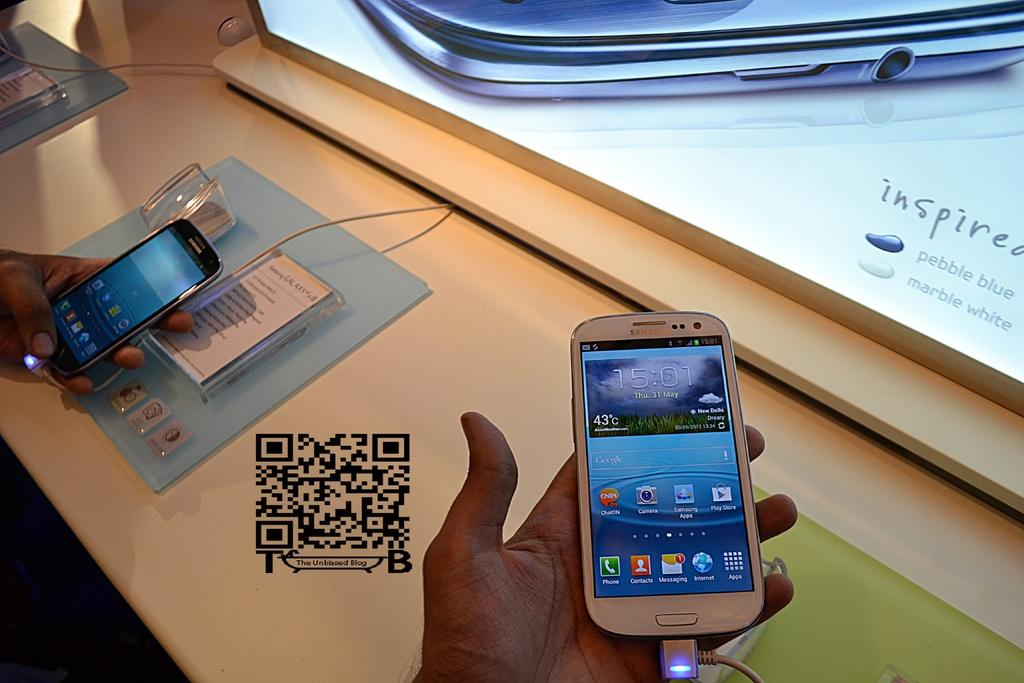<image>
Relay a brief, clear account of the picture shown. A white phone by Samsung is being held by a hand. 